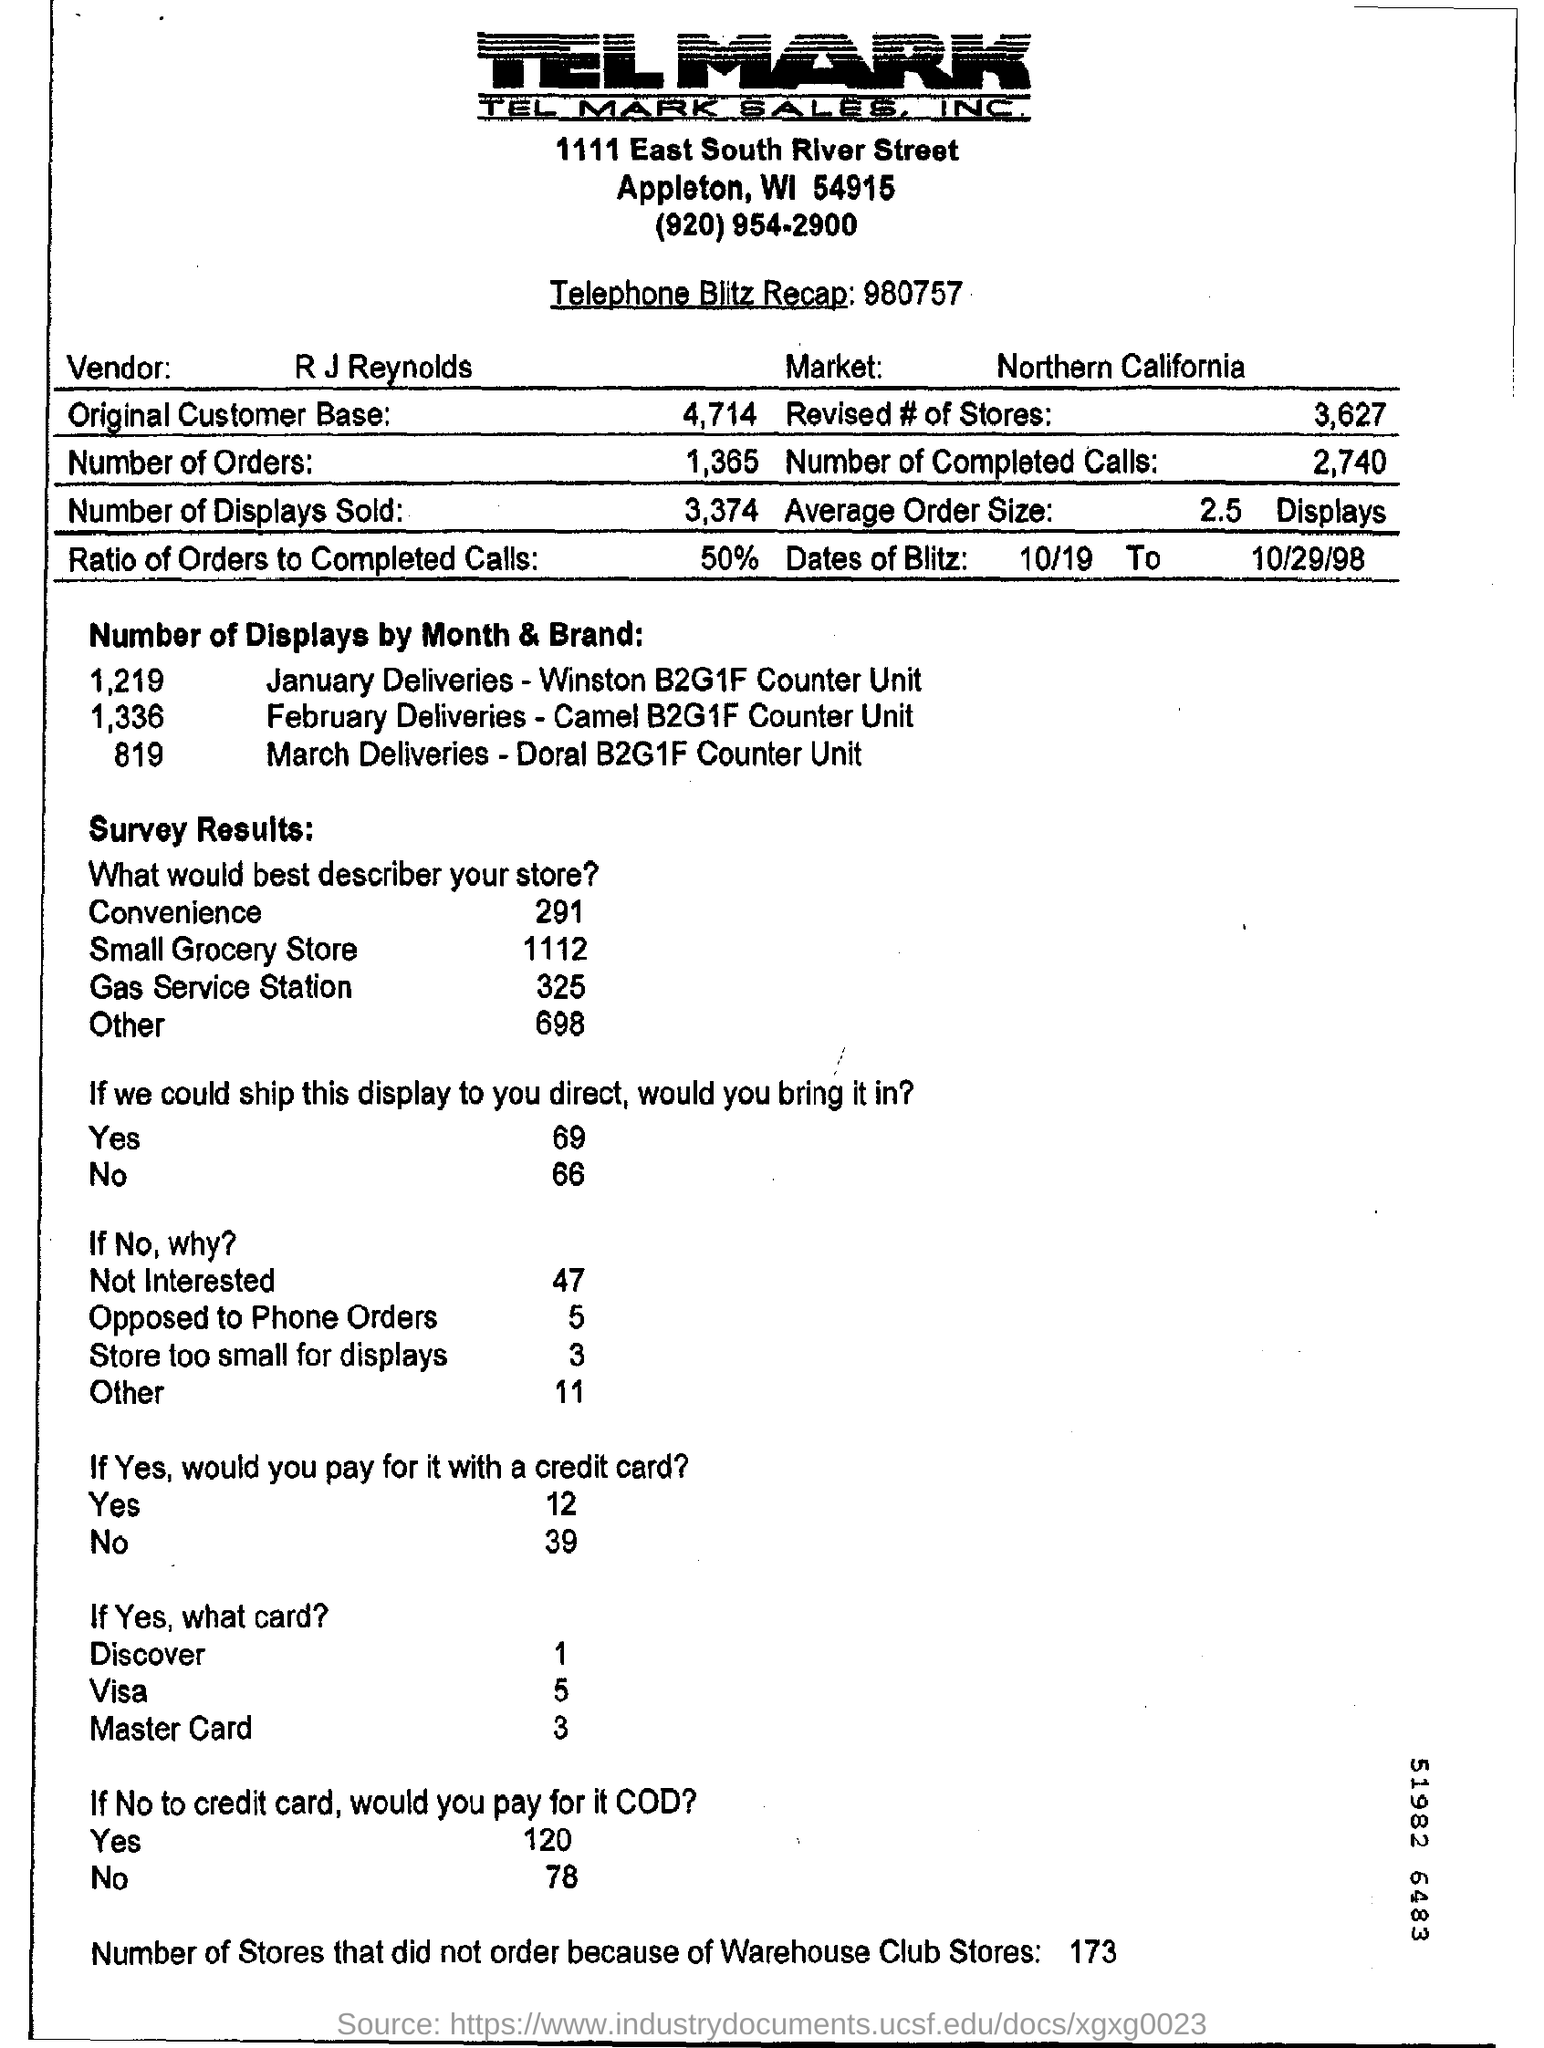Name of the vendor is
Provide a short and direct response. R J Reynolds. What is the name of the market
Provide a short and direct response. Northern California. What are the number of orders
Your answer should be very brief. 1,365. Number of stores that did not order because of warehouse club stores are
Ensure brevity in your answer.  173. What number is telephone blitz recap
Give a very brief answer. 980757. Ratio of orders to completed calls are
Keep it short and to the point. 50%. What is the average order size displays
Give a very brief answer. 2.5 Displays. 